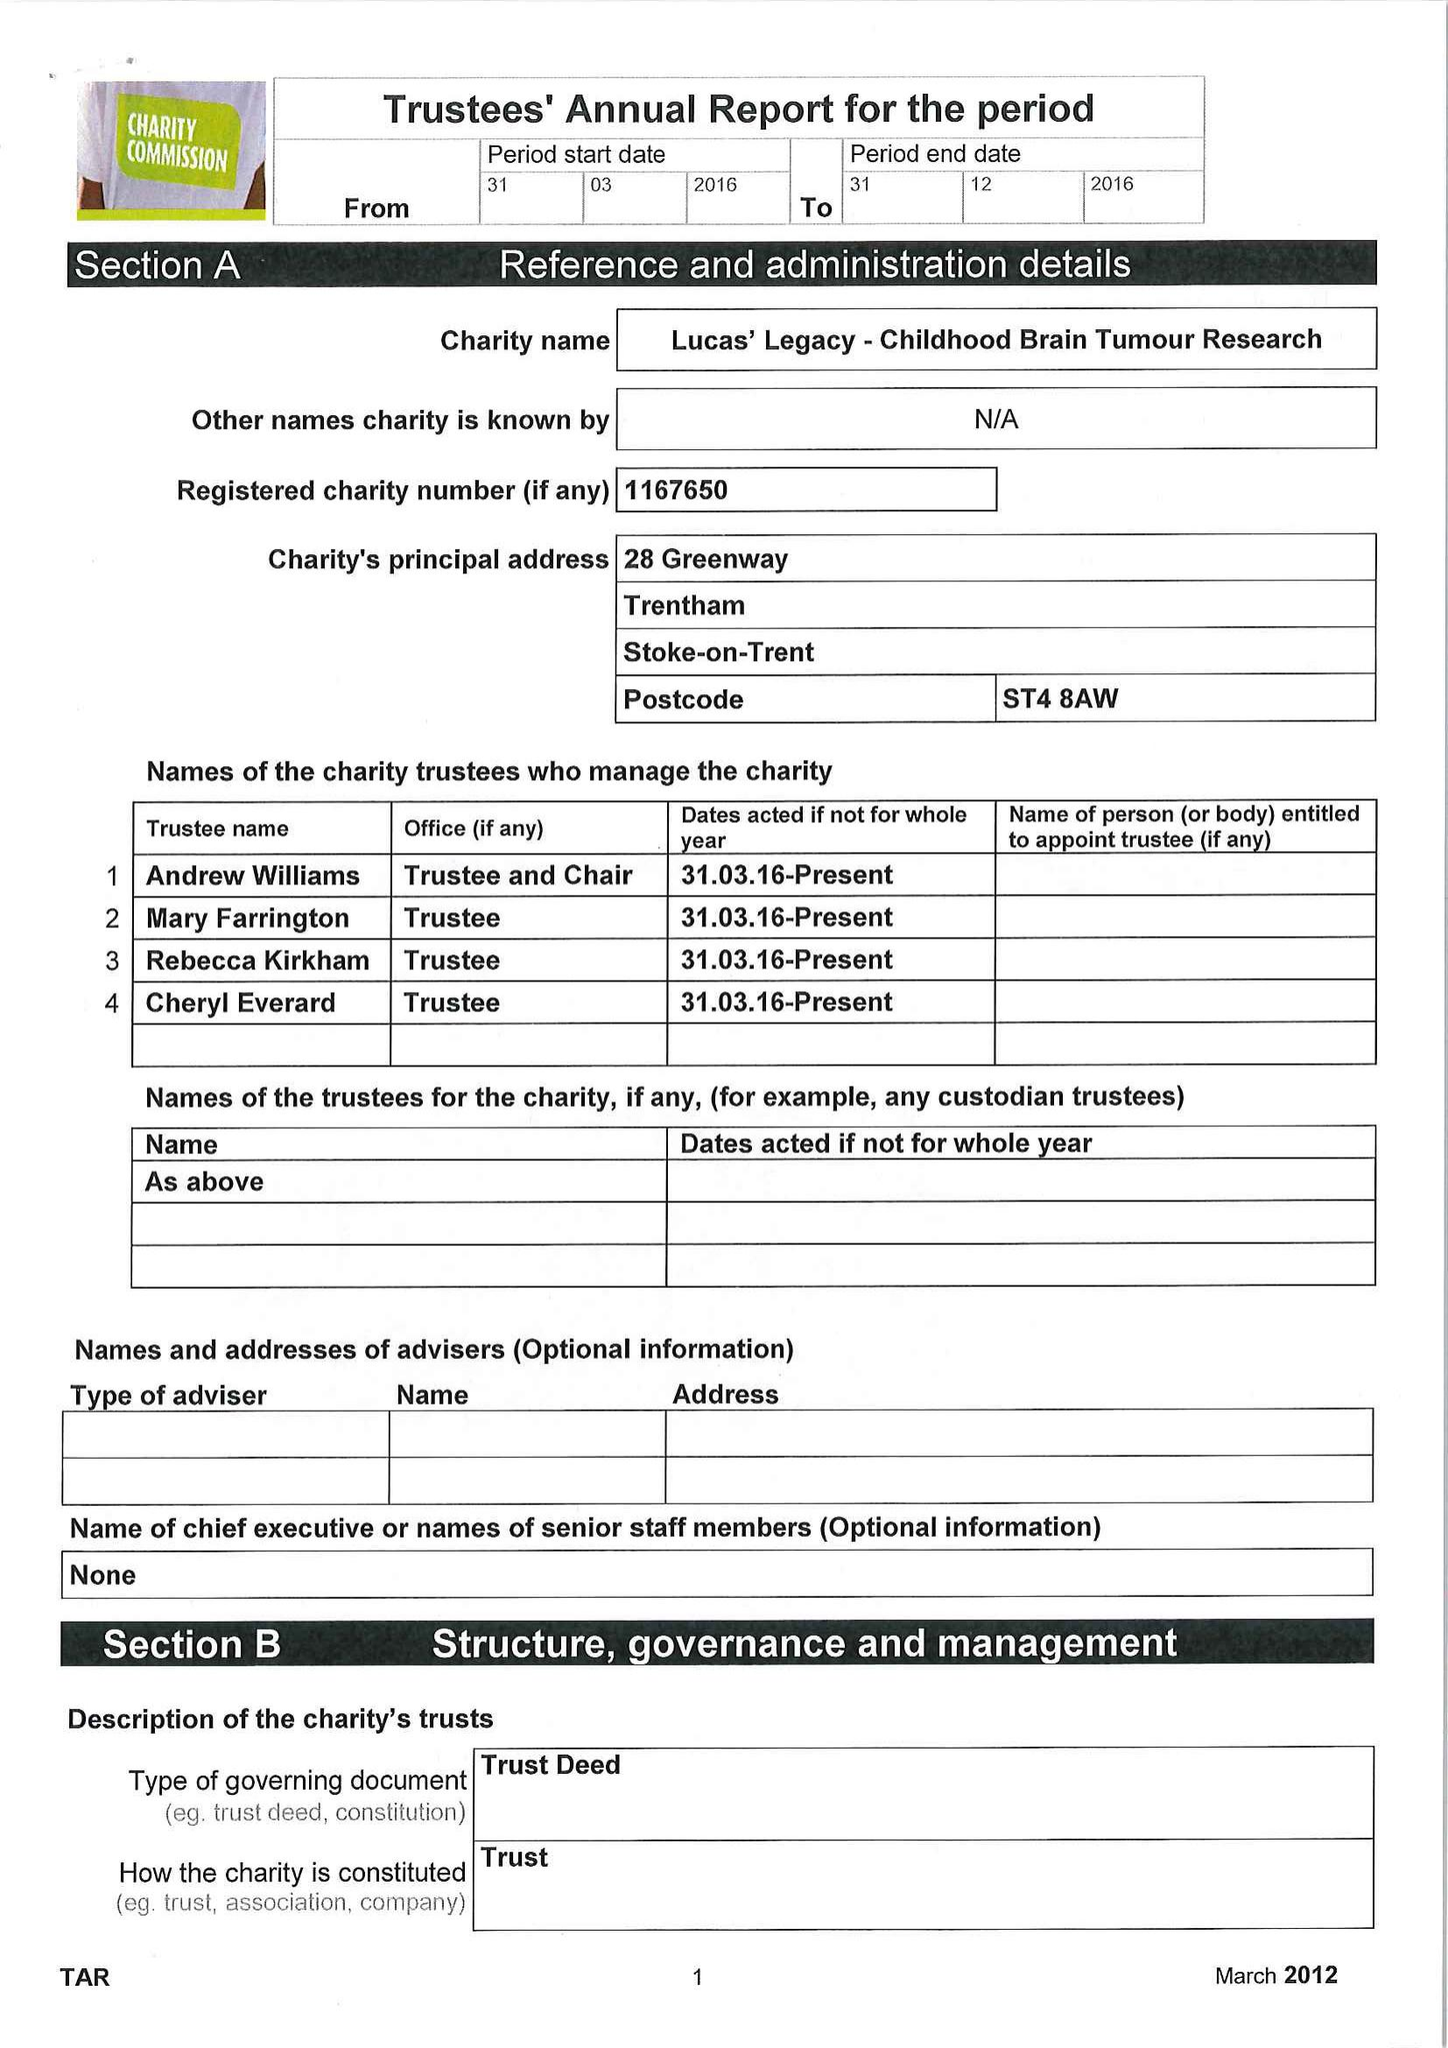What is the value for the report_date?
Answer the question using a single word or phrase. 2016-12-31 